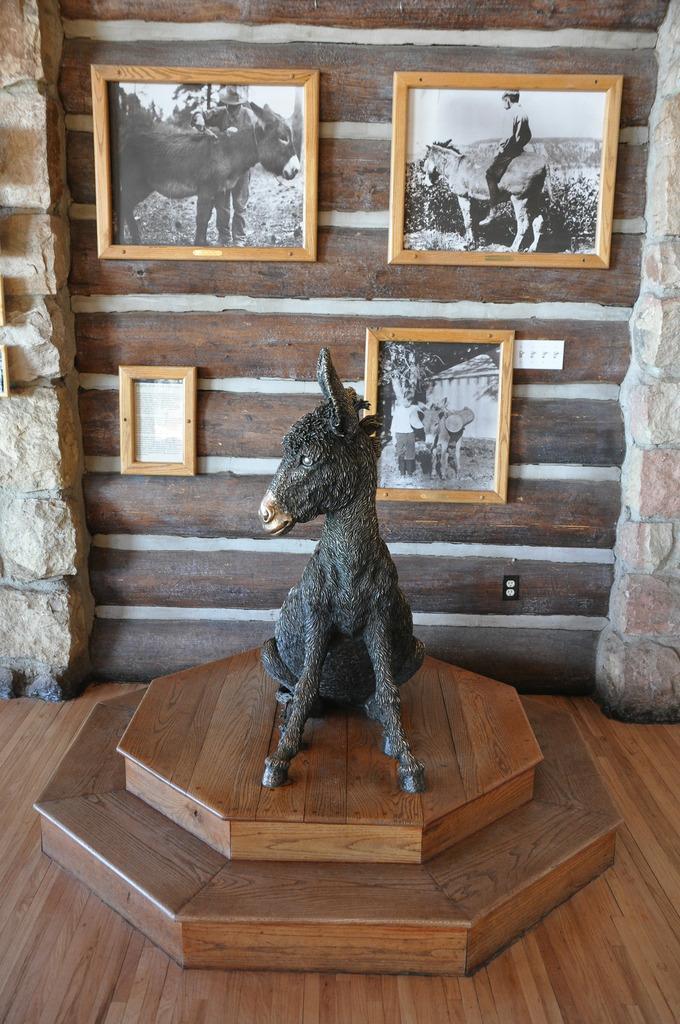Describe this image in one or two sentences. In this picture I see the brown color surface in front on which there is a sculpture of an animal. In the background I see the wall on which there are photo frames and I see few animals and few persons on the frames. 